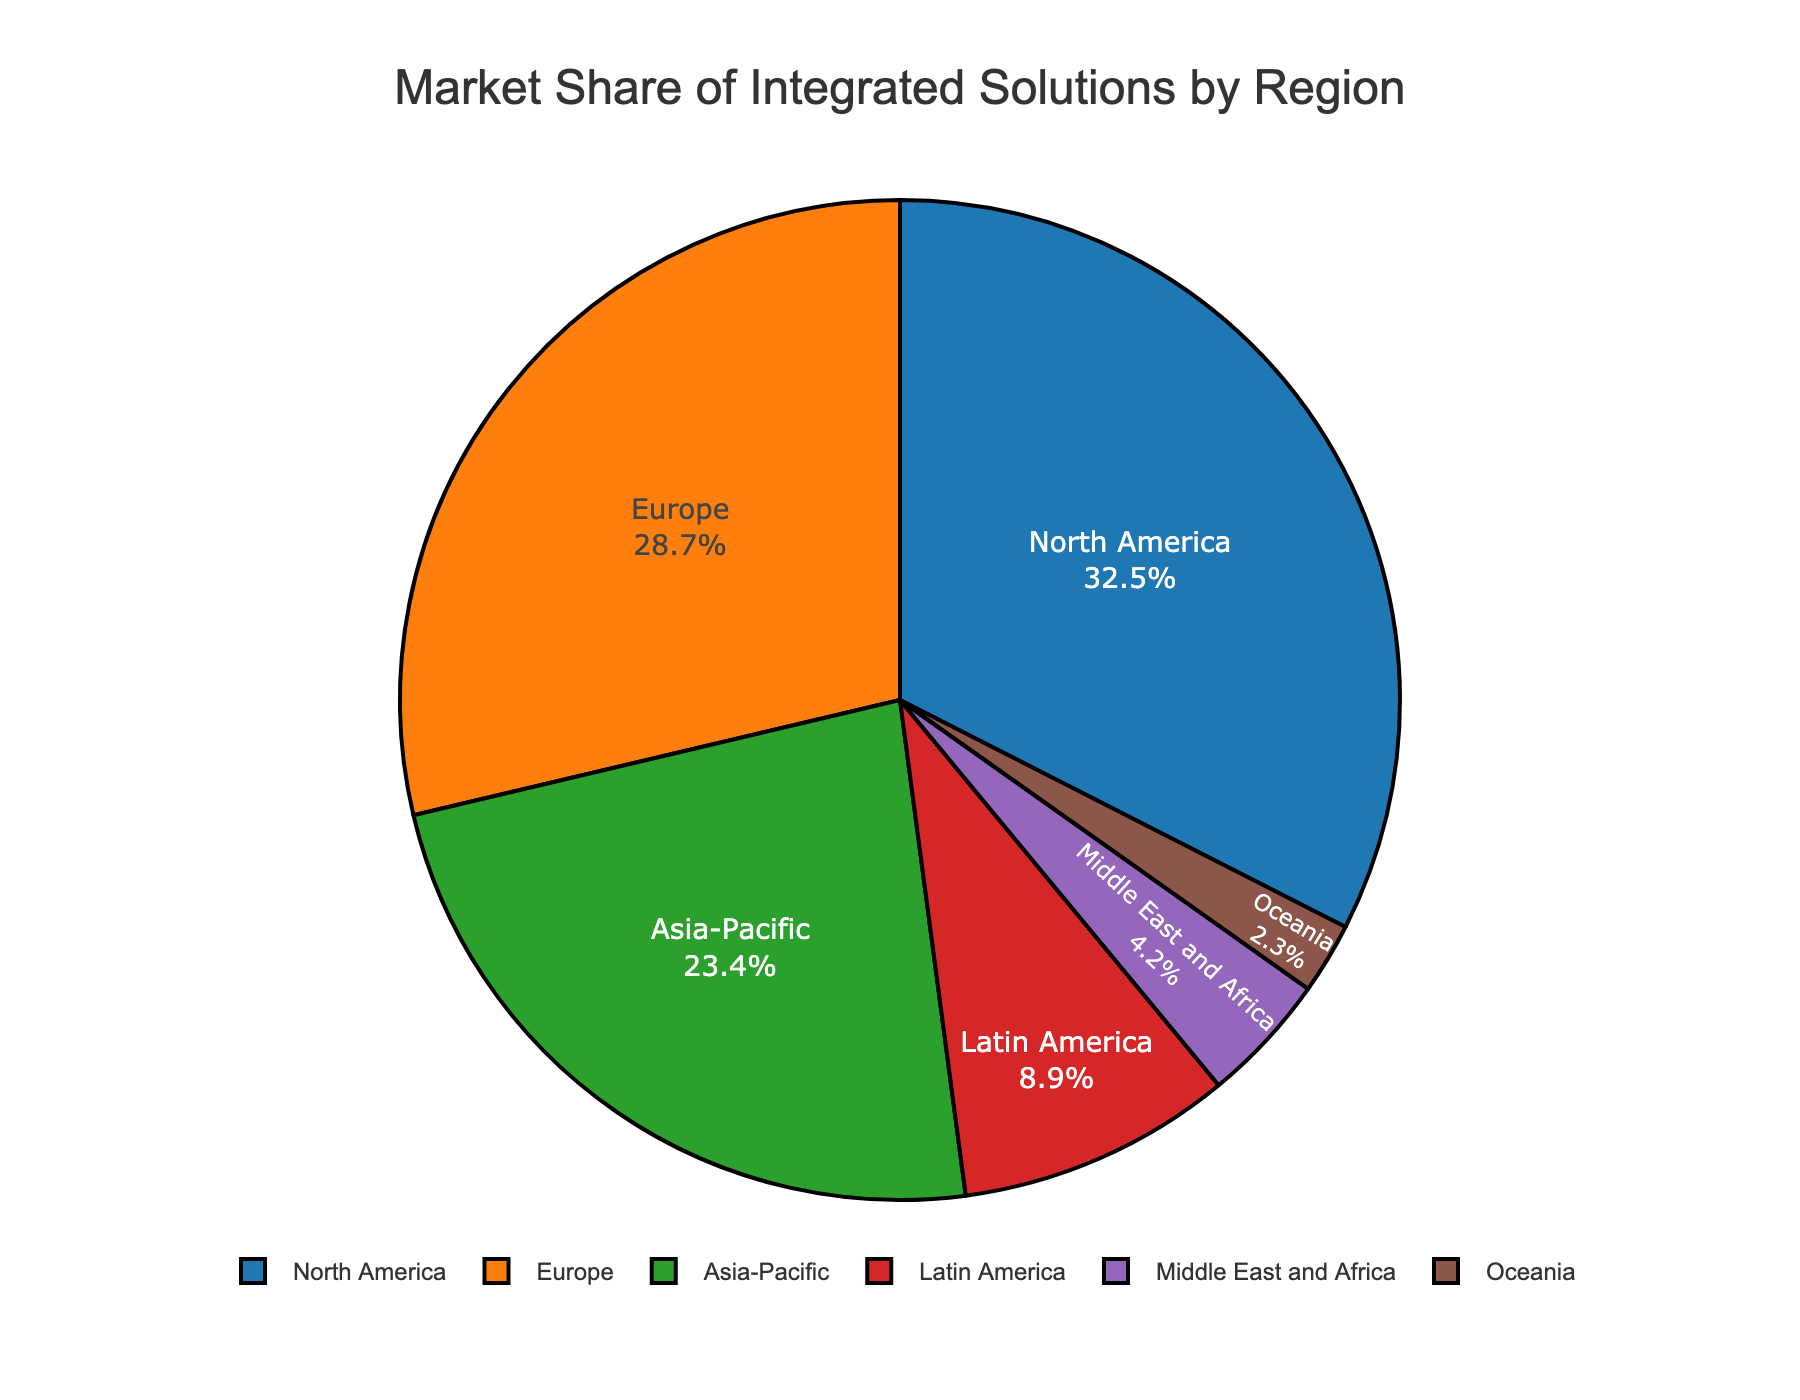Which region has the highest market share? The pie chart shows multiple regions with their respective market shares represented as segments. North America has the largest segment with a 32.5% market share.
Answer: North America Which regions combined make up more than 60% of the market share? By visually adding the segments, North America (32.5%) and Europe (28.7%) sum up to 61.2%.
Answer: North America and Europe What is the total market share of regions outside Asia-Pacific, Latin America, and Oceania? Summing the market shares of North America (32.5%), Europe (28.7%), and Middle East and Africa (4.2%) yields 32.5 + 28.7 + 4.2 = 65.4%.
Answer: 65.4% Which region has a market share less than 5%? The smallest segments of the pie chart belong to Middle East and Africa (4.2%) and Oceania (2.3%). Both are less than 5%.
Answer: Middle East and Africa and Oceania Which region’s market share is closest to a quarter of the total market? A quarter of the total market is 25%. Asia-Pacific's segment closely matches this with a market share of 23.4%.
Answer: Asia-Pacific Is Latin America’s market share greater than the combined market shares of the Middle East and Africa and Oceania? Latin America has a market share of 8.9%. Middle East and Africa and Oceania together have 4.2 + 2.3 = 6.5%. Since 8.9% is greater than 6.5%, Latin America's market share is indeed greater.
Answer: Yes What is the combined market share of the three regions with the lowest shares? The three regions with the smallest shares are Oceania (2.3%), Middle East and Africa (4.2%), and Latin America (8.9%). Summing these gives 2.3 + 4.2 + 8.9 = 15.4%.
Answer: 15.4% If Europe’s market share increased by 10%, what would its new share be? Europe currently has a 28.7% share. An increase of 10% of its original value would be 28.7 * 1.1 = 31.57%.
Answer: 31.57% How much more market share does North America have than Latin America? North America has 32.5%, and Latin America has 8.9%. The difference is 32.5 - 8.9 = 23.6%.
Answer: 23.6% 